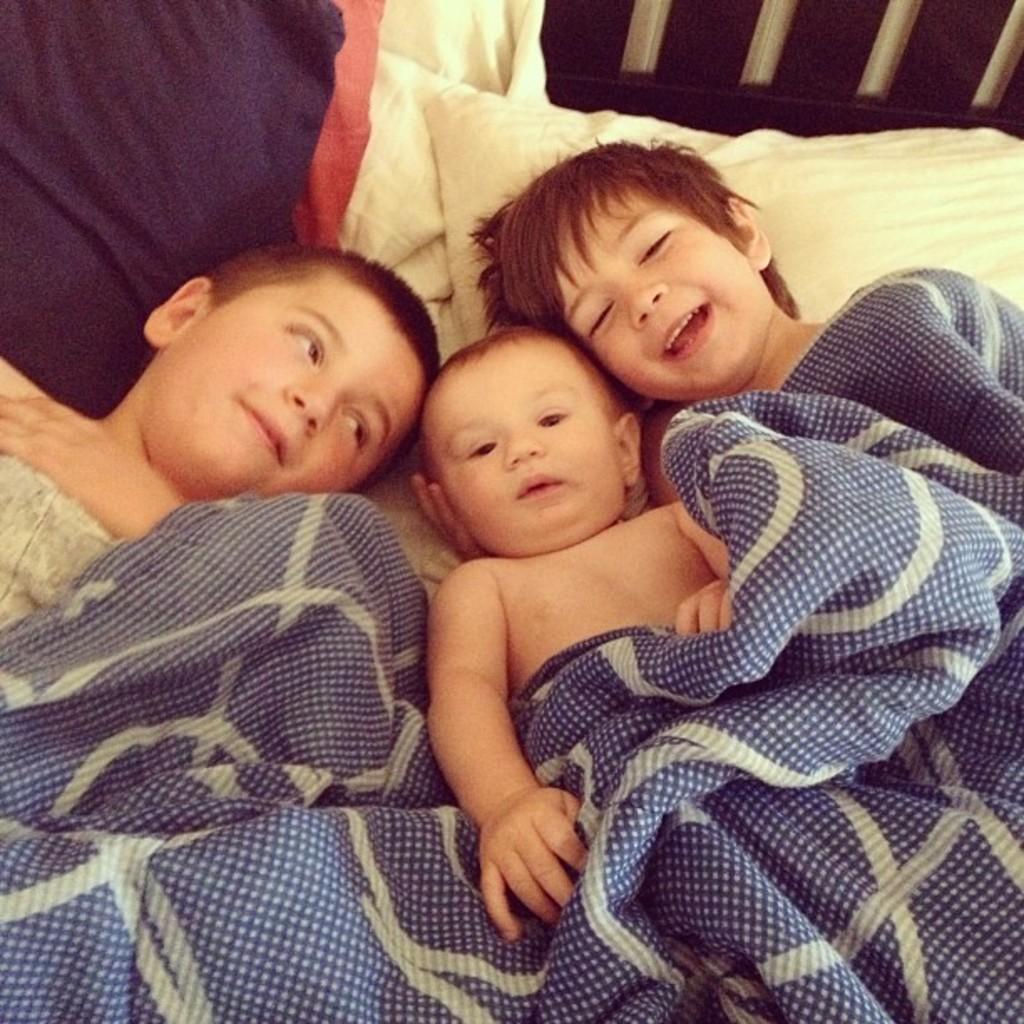Could you give a brief overview of what you see in this image? Here we can see a baby and two boys on the either side of this baby. They are on a bed. 